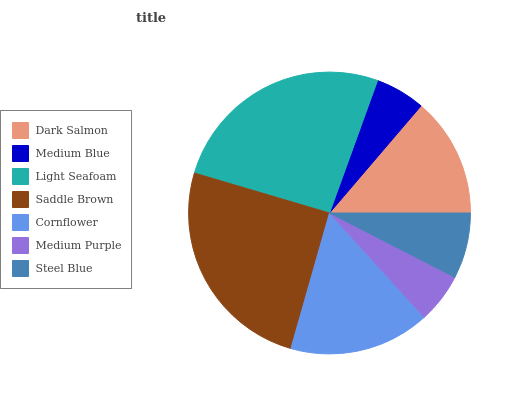Is Medium Blue the minimum?
Answer yes or no. Yes. Is Light Seafoam the maximum?
Answer yes or no. Yes. Is Light Seafoam the minimum?
Answer yes or no. No. Is Medium Blue the maximum?
Answer yes or no. No. Is Light Seafoam greater than Medium Blue?
Answer yes or no. Yes. Is Medium Blue less than Light Seafoam?
Answer yes or no. Yes. Is Medium Blue greater than Light Seafoam?
Answer yes or no. No. Is Light Seafoam less than Medium Blue?
Answer yes or no. No. Is Dark Salmon the high median?
Answer yes or no. Yes. Is Dark Salmon the low median?
Answer yes or no. Yes. Is Saddle Brown the high median?
Answer yes or no. No. Is Light Seafoam the low median?
Answer yes or no. No. 